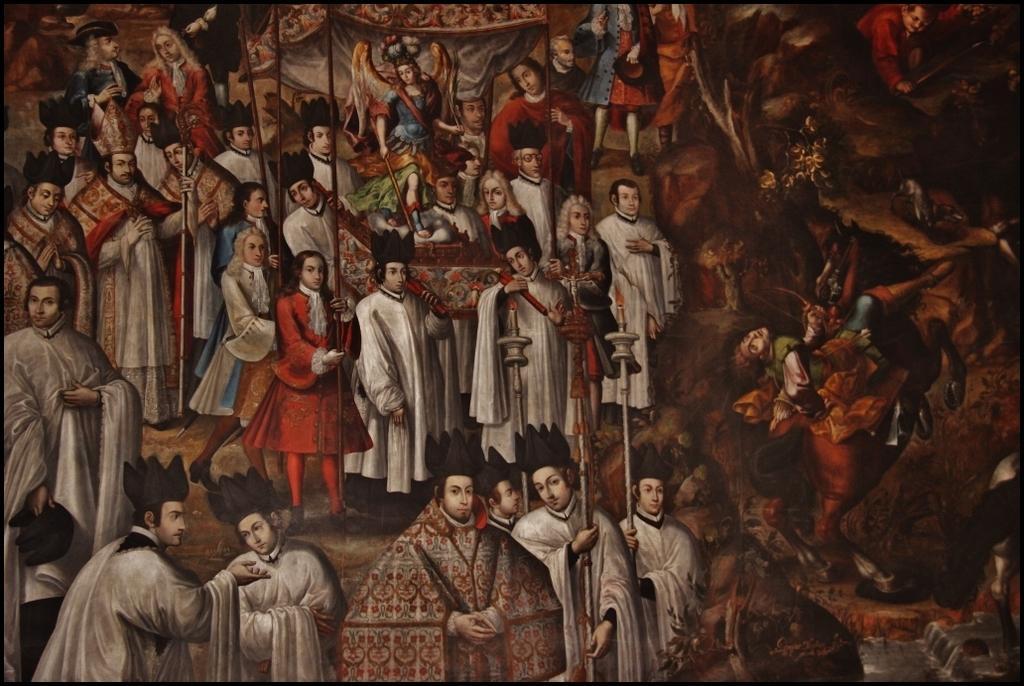Can you describe this image briefly? This picture is a painting. In this image there are group of people. In the foreground there are two persons standing and holding the objects. In the middle of the image there are group of people holding the sculpture. 